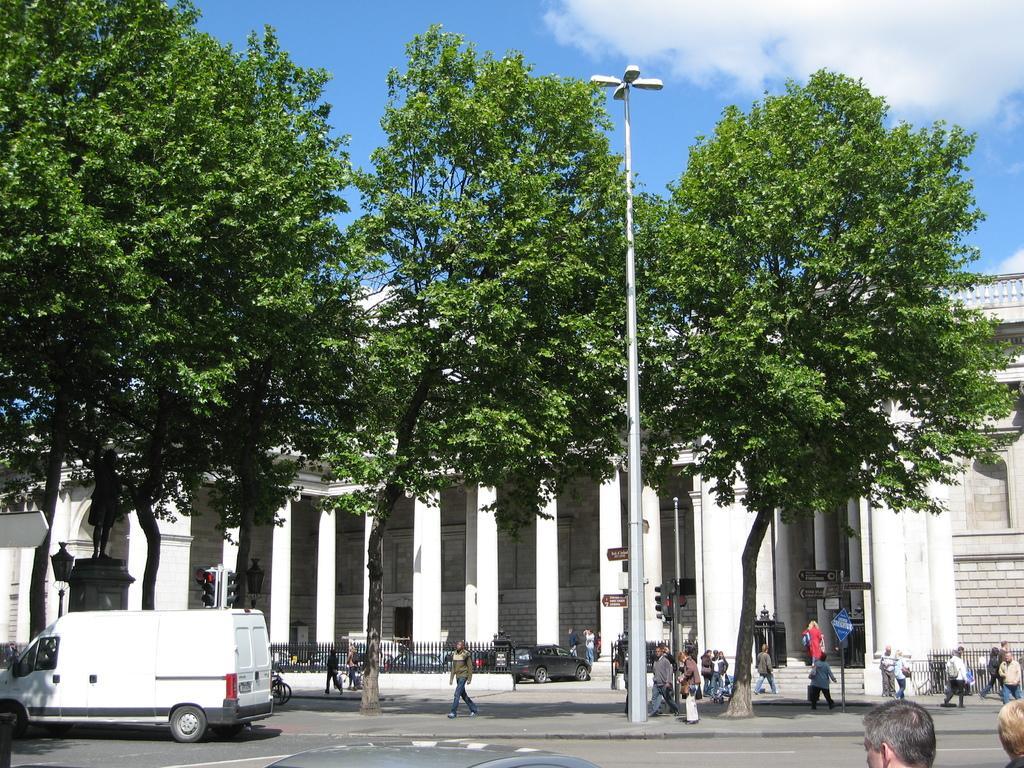How would you summarize this image in a sentence or two? In this image there is a road in the middle. On the road there is a white colour van. In the middle there is a pole to which there are four lights. In the background there is a building with the pillars. On the right side there are few people walking on the road. There are trees on the footpath. 